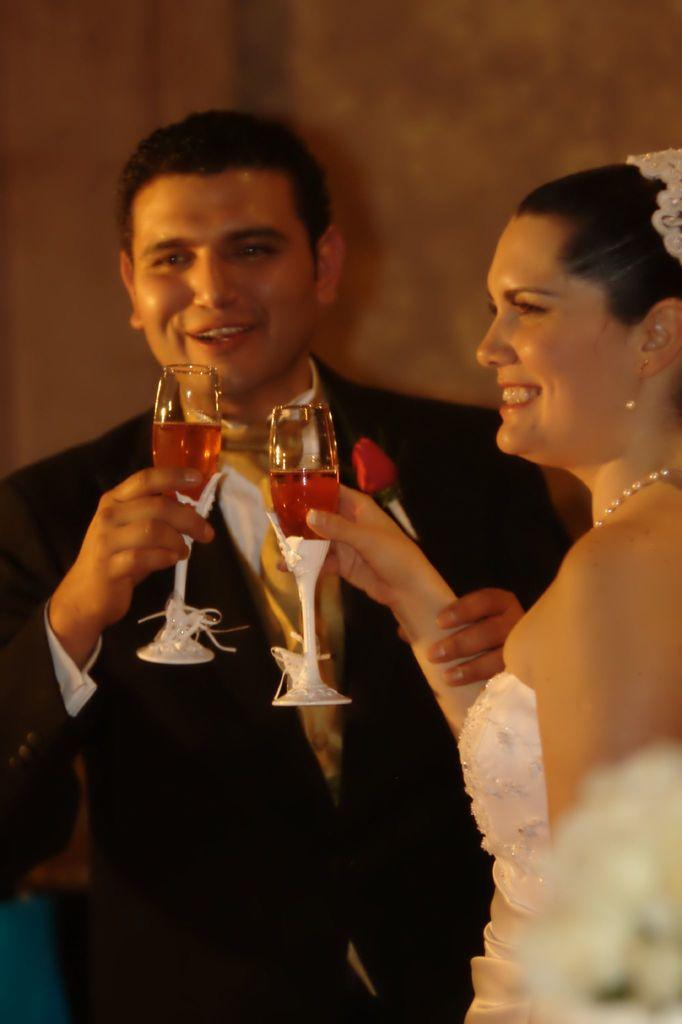How many people are in the image? There are two persons standing in the image. What are the persons holding in their hands? Both persons are holding a glass with a drink. What is the facial expression of the persons in the image? Both persons are smiling. Are the persons interacting with each other in the image? Yes, one person is holding the other person's hand. What can be seen in the background of the image? There is a wall in the background of the image. What type of parcel is being delivered to the persons in the image? There is no parcel present in the image; it only shows two persons standing and holding glasses with a drink. What route are the persons taking in the image? There is no indication of a route in the image, as it only shows two persons standing and holding glasses with a drink. 